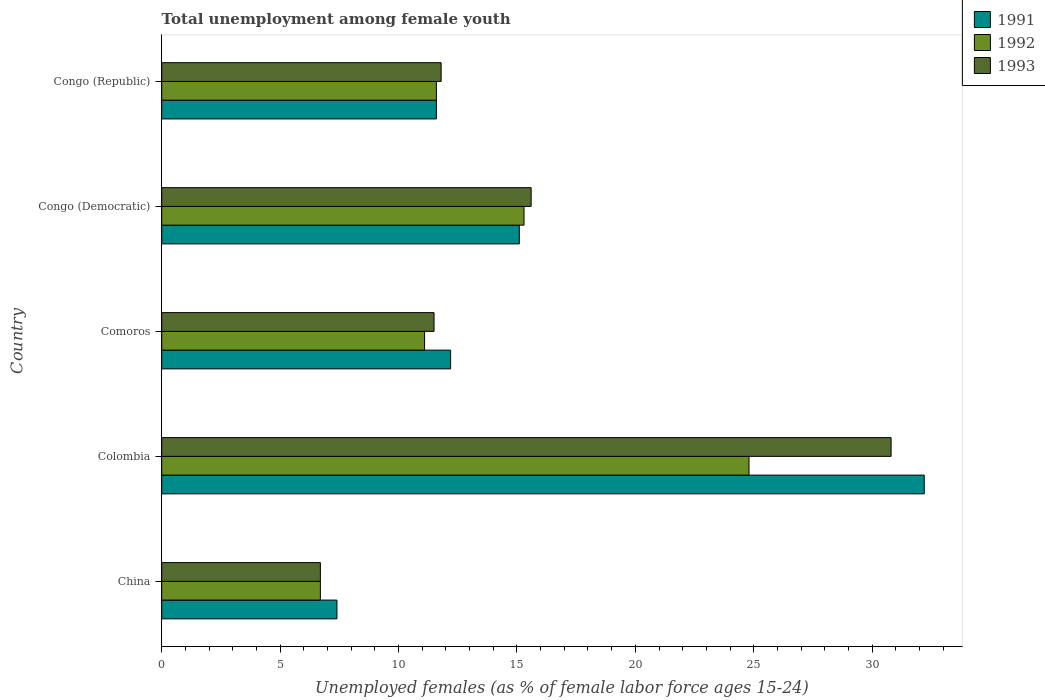How many different coloured bars are there?
Ensure brevity in your answer.  3. Are the number of bars on each tick of the Y-axis equal?
Your answer should be compact. Yes. How many bars are there on the 5th tick from the top?
Your response must be concise. 3. How many bars are there on the 3rd tick from the bottom?
Your answer should be compact. 3. What is the label of the 5th group of bars from the top?
Make the answer very short. China. In how many cases, is the number of bars for a given country not equal to the number of legend labels?
Your answer should be very brief. 0. What is the percentage of unemployed females in in 1993 in China?
Provide a succinct answer. 6.7. Across all countries, what is the maximum percentage of unemployed females in in 1992?
Ensure brevity in your answer.  24.8. Across all countries, what is the minimum percentage of unemployed females in in 1991?
Your answer should be very brief. 7.4. In which country was the percentage of unemployed females in in 1993 maximum?
Offer a terse response. Colombia. What is the total percentage of unemployed females in in 1993 in the graph?
Offer a terse response. 76.4. What is the difference between the percentage of unemployed females in in 1991 in Colombia and that in Congo (Republic)?
Your answer should be compact. 20.6. What is the difference between the percentage of unemployed females in in 1991 in China and the percentage of unemployed females in in 1993 in Colombia?
Offer a terse response. -23.4. What is the average percentage of unemployed females in in 1992 per country?
Keep it short and to the point. 13.9. What is the difference between the percentage of unemployed females in in 1993 and percentage of unemployed females in in 1992 in China?
Provide a short and direct response. 0. In how many countries, is the percentage of unemployed females in in 1991 greater than 11 %?
Keep it short and to the point. 4. What is the ratio of the percentage of unemployed females in in 1993 in Congo (Democratic) to that in Congo (Republic)?
Your answer should be very brief. 1.32. Is the percentage of unemployed females in in 1993 in Colombia less than that in Congo (Democratic)?
Give a very brief answer. No. Is the difference between the percentage of unemployed females in in 1993 in China and Colombia greater than the difference between the percentage of unemployed females in in 1992 in China and Colombia?
Keep it short and to the point. No. What is the difference between the highest and the second highest percentage of unemployed females in in 1993?
Make the answer very short. 15.2. What is the difference between the highest and the lowest percentage of unemployed females in in 1991?
Provide a short and direct response. 24.8. In how many countries, is the percentage of unemployed females in in 1993 greater than the average percentage of unemployed females in in 1993 taken over all countries?
Your answer should be very brief. 2. Is the sum of the percentage of unemployed females in in 1992 in Comoros and Congo (Democratic) greater than the maximum percentage of unemployed females in in 1991 across all countries?
Make the answer very short. No. What does the 2nd bar from the bottom in China represents?
Your response must be concise. 1992. Are all the bars in the graph horizontal?
Provide a succinct answer. Yes. How many countries are there in the graph?
Your answer should be compact. 5. Does the graph contain grids?
Your answer should be compact. No. How many legend labels are there?
Your response must be concise. 3. How are the legend labels stacked?
Your answer should be compact. Vertical. What is the title of the graph?
Provide a succinct answer. Total unemployment among female youth. Does "2009" appear as one of the legend labels in the graph?
Offer a terse response. No. What is the label or title of the X-axis?
Give a very brief answer. Unemployed females (as % of female labor force ages 15-24). What is the Unemployed females (as % of female labor force ages 15-24) in 1991 in China?
Your answer should be very brief. 7.4. What is the Unemployed females (as % of female labor force ages 15-24) of 1992 in China?
Your answer should be very brief. 6.7. What is the Unemployed females (as % of female labor force ages 15-24) in 1993 in China?
Offer a terse response. 6.7. What is the Unemployed females (as % of female labor force ages 15-24) in 1991 in Colombia?
Offer a terse response. 32.2. What is the Unemployed females (as % of female labor force ages 15-24) in 1992 in Colombia?
Ensure brevity in your answer.  24.8. What is the Unemployed females (as % of female labor force ages 15-24) of 1993 in Colombia?
Provide a succinct answer. 30.8. What is the Unemployed females (as % of female labor force ages 15-24) of 1991 in Comoros?
Your answer should be very brief. 12.2. What is the Unemployed females (as % of female labor force ages 15-24) in 1992 in Comoros?
Ensure brevity in your answer.  11.1. What is the Unemployed females (as % of female labor force ages 15-24) of 1993 in Comoros?
Give a very brief answer. 11.5. What is the Unemployed females (as % of female labor force ages 15-24) in 1991 in Congo (Democratic)?
Keep it short and to the point. 15.1. What is the Unemployed females (as % of female labor force ages 15-24) in 1992 in Congo (Democratic)?
Give a very brief answer. 15.3. What is the Unemployed females (as % of female labor force ages 15-24) in 1993 in Congo (Democratic)?
Your answer should be compact. 15.6. What is the Unemployed females (as % of female labor force ages 15-24) of 1991 in Congo (Republic)?
Your response must be concise. 11.6. What is the Unemployed females (as % of female labor force ages 15-24) of 1992 in Congo (Republic)?
Provide a succinct answer. 11.6. What is the Unemployed females (as % of female labor force ages 15-24) in 1993 in Congo (Republic)?
Offer a very short reply. 11.8. Across all countries, what is the maximum Unemployed females (as % of female labor force ages 15-24) in 1991?
Give a very brief answer. 32.2. Across all countries, what is the maximum Unemployed females (as % of female labor force ages 15-24) in 1992?
Ensure brevity in your answer.  24.8. Across all countries, what is the maximum Unemployed females (as % of female labor force ages 15-24) in 1993?
Ensure brevity in your answer.  30.8. Across all countries, what is the minimum Unemployed females (as % of female labor force ages 15-24) in 1991?
Your response must be concise. 7.4. Across all countries, what is the minimum Unemployed females (as % of female labor force ages 15-24) of 1992?
Provide a succinct answer. 6.7. Across all countries, what is the minimum Unemployed females (as % of female labor force ages 15-24) of 1993?
Keep it short and to the point. 6.7. What is the total Unemployed females (as % of female labor force ages 15-24) in 1991 in the graph?
Your answer should be very brief. 78.5. What is the total Unemployed females (as % of female labor force ages 15-24) in 1992 in the graph?
Your answer should be compact. 69.5. What is the total Unemployed females (as % of female labor force ages 15-24) of 1993 in the graph?
Your response must be concise. 76.4. What is the difference between the Unemployed females (as % of female labor force ages 15-24) in 1991 in China and that in Colombia?
Your answer should be compact. -24.8. What is the difference between the Unemployed females (as % of female labor force ages 15-24) in 1992 in China and that in Colombia?
Offer a very short reply. -18.1. What is the difference between the Unemployed females (as % of female labor force ages 15-24) of 1993 in China and that in Colombia?
Offer a very short reply. -24.1. What is the difference between the Unemployed females (as % of female labor force ages 15-24) in 1991 in China and that in Comoros?
Make the answer very short. -4.8. What is the difference between the Unemployed females (as % of female labor force ages 15-24) in 1991 in China and that in Congo (Democratic)?
Keep it short and to the point. -7.7. What is the difference between the Unemployed females (as % of female labor force ages 15-24) in 1991 in China and that in Congo (Republic)?
Your answer should be compact. -4.2. What is the difference between the Unemployed females (as % of female labor force ages 15-24) in 1993 in China and that in Congo (Republic)?
Provide a succinct answer. -5.1. What is the difference between the Unemployed females (as % of female labor force ages 15-24) in 1992 in Colombia and that in Comoros?
Provide a short and direct response. 13.7. What is the difference between the Unemployed females (as % of female labor force ages 15-24) in 1993 in Colombia and that in Comoros?
Provide a succinct answer. 19.3. What is the difference between the Unemployed females (as % of female labor force ages 15-24) of 1991 in Colombia and that in Congo (Democratic)?
Keep it short and to the point. 17.1. What is the difference between the Unemployed females (as % of female labor force ages 15-24) in 1993 in Colombia and that in Congo (Democratic)?
Ensure brevity in your answer.  15.2. What is the difference between the Unemployed females (as % of female labor force ages 15-24) of 1991 in Colombia and that in Congo (Republic)?
Give a very brief answer. 20.6. What is the difference between the Unemployed females (as % of female labor force ages 15-24) in 1993 in Colombia and that in Congo (Republic)?
Your response must be concise. 19. What is the difference between the Unemployed females (as % of female labor force ages 15-24) of 1991 in Comoros and that in Congo (Democratic)?
Offer a terse response. -2.9. What is the difference between the Unemployed females (as % of female labor force ages 15-24) of 1992 in Comoros and that in Congo (Democratic)?
Make the answer very short. -4.2. What is the difference between the Unemployed females (as % of female labor force ages 15-24) of 1993 in Comoros and that in Congo (Democratic)?
Your answer should be compact. -4.1. What is the difference between the Unemployed females (as % of female labor force ages 15-24) of 1992 in Comoros and that in Congo (Republic)?
Make the answer very short. -0.5. What is the difference between the Unemployed females (as % of female labor force ages 15-24) in 1993 in Comoros and that in Congo (Republic)?
Keep it short and to the point. -0.3. What is the difference between the Unemployed females (as % of female labor force ages 15-24) of 1993 in Congo (Democratic) and that in Congo (Republic)?
Offer a terse response. 3.8. What is the difference between the Unemployed females (as % of female labor force ages 15-24) of 1991 in China and the Unemployed females (as % of female labor force ages 15-24) of 1992 in Colombia?
Give a very brief answer. -17.4. What is the difference between the Unemployed females (as % of female labor force ages 15-24) of 1991 in China and the Unemployed females (as % of female labor force ages 15-24) of 1993 in Colombia?
Provide a succinct answer. -23.4. What is the difference between the Unemployed females (as % of female labor force ages 15-24) in 1992 in China and the Unemployed females (as % of female labor force ages 15-24) in 1993 in Colombia?
Offer a very short reply. -24.1. What is the difference between the Unemployed females (as % of female labor force ages 15-24) in 1991 in China and the Unemployed females (as % of female labor force ages 15-24) in 1993 in Comoros?
Provide a short and direct response. -4.1. What is the difference between the Unemployed females (as % of female labor force ages 15-24) in 1992 in China and the Unemployed females (as % of female labor force ages 15-24) in 1993 in Comoros?
Your answer should be compact. -4.8. What is the difference between the Unemployed females (as % of female labor force ages 15-24) of 1991 in China and the Unemployed females (as % of female labor force ages 15-24) of 1992 in Congo (Democratic)?
Provide a succinct answer. -7.9. What is the difference between the Unemployed females (as % of female labor force ages 15-24) of 1991 in China and the Unemployed females (as % of female labor force ages 15-24) of 1993 in Congo (Democratic)?
Offer a very short reply. -8.2. What is the difference between the Unemployed females (as % of female labor force ages 15-24) of 1991 in Colombia and the Unemployed females (as % of female labor force ages 15-24) of 1992 in Comoros?
Offer a very short reply. 21.1. What is the difference between the Unemployed females (as % of female labor force ages 15-24) in 1991 in Colombia and the Unemployed females (as % of female labor force ages 15-24) in 1993 in Comoros?
Make the answer very short. 20.7. What is the difference between the Unemployed females (as % of female labor force ages 15-24) of 1992 in Colombia and the Unemployed females (as % of female labor force ages 15-24) of 1993 in Congo (Democratic)?
Keep it short and to the point. 9.2. What is the difference between the Unemployed females (as % of female labor force ages 15-24) of 1991 in Colombia and the Unemployed females (as % of female labor force ages 15-24) of 1992 in Congo (Republic)?
Your response must be concise. 20.6. What is the difference between the Unemployed females (as % of female labor force ages 15-24) in 1991 in Colombia and the Unemployed females (as % of female labor force ages 15-24) in 1993 in Congo (Republic)?
Ensure brevity in your answer.  20.4. What is the difference between the Unemployed females (as % of female labor force ages 15-24) in 1991 in Comoros and the Unemployed females (as % of female labor force ages 15-24) in 1992 in Congo (Republic)?
Keep it short and to the point. 0.6. What is the difference between the Unemployed females (as % of female labor force ages 15-24) of 1991 in Comoros and the Unemployed females (as % of female labor force ages 15-24) of 1993 in Congo (Republic)?
Provide a short and direct response. 0.4. What is the difference between the Unemployed females (as % of female labor force ages 15-24) of 1991 in Congo (Democratic) and the Unemployed females (as % of female labor force ages 15-24) of 1992 in Congo (Republic)?
Give a very brief answer. 3.5. What is the difference between the Unemployed females (as % of female labor force ages 15-24) in 1992 in Congo (Democratic) and the Unemployed females (as % of female labor force ages 15-24) in 1993 in Congo (Republic)?
Give a very brief answer. 3.5. What is the average Unemployed females (as % of female labor force ages 15-24) of 1993 per country?
Make the answer very short. 15.28. What is the difference between the Unemployed females (as % of female labor force ages 15-24) of 1991 and Unemployed females (as % of female labor force ages 15-24) of 1992 in China?
Keep it short and to the point. 0.7. What is the difference between the Unemployed females (as % of female labor force ages 15-24) of 1992 and Unemployed females (as % of female labor force ages 15-24) of 1993 in China?
Keep it short and to the point. 0. What is the difference between the Unemployed females (as % of female labor force ages 15-24) in 1992 and Unemployed females (as % of female labor force ages 15-24) in 1993 in Comoros?
Keep it short and to the point. -0.4. What is the difference between the Unemployed females (as % of female labor force ages 15-24) in 1991 and Unemployed females (as % of female labor force ages 15-24) in 1992 in Congo (Democratic)?
Your answer should be very brief. -0.2. What is the difference between the Unemployed females (as % of female labor force ages 15-24) of 1991 and Unemployed females (as % of female labor force ages 15-24) of 1993 in Congo (Democratic)?
Make the answer very short. -0.5. What is the difference between the Unemployed females (as % of female labor force ages 15-24) in 1992 and Unemployed females (as % of female labor force ages 15-24) in 1993 in Congo (Democratic)?
Your answer should be very brief. -0.3. What is the ratio of the Unemployed females (as % of female labor force ages 15-24) in 1991 in China to that in Colombia?
Your answer should be compact. 0.23. What is the ratio of the Unemployed females (as % of female labor force ages 15-24) of 1992 in China to that in Colombia?
Your answer should be very brief. 0.27. What is the ratio of the Unemployed females (as % of female labor force ages 15-24) of 1993 in China to that in Colombia?
Offer a very short reply. 0.22. What is the ratio of the Unemployed females (as % of female labor force ages 15-24) in 1991 in China to that in Comoros?
Make the answer very short. 0.61. What is the ratio of the Unemployed females (as % of female labor force ages 15-24) of 1992 in China to that in Comoros?
Provide a short and direct response. 0.6. What is the ratio of the Unemployed females (as % of female labor force ages 15-24) in 1993 in China to that in Comoros?
Offer a terse response. 0.58. What is the ratio of the Unemployed females (as % of female labor force ages 15-24) in 1991 in China to that in Congo (Democratic)?
Keep it short and to the point. 0.49. What is the ratio of the Unemployed females (as % of female labor force ages 15-24) of 1992 in China to that in Congo (Democratic)?
Offer a very short reply. 0.44. What is the ratio of the Unemployed females (as % of female labor force ages 15-24) in 1993 in China to that in Congo (Democratic)?
Your response must be concise. 0.43. What is the ratio of the Unemployed females (as % of female labor force ages 15-24) in 1991 in China to that in Congo (Republic)?
Keep it short and to the point. 0.64. What is the ratio of the Unemployed females (as % of female labor force ages 15-24) of 1992 in China to that in Congo (Republic)?
Keep it short and to the point. 0.58. What is the ratio of the Unemployed females (as % of female labor force ages 15-24) in 1993 in China to that in Congo (Republic)?
Offer a terse response. 0.57. What is the ratio of the Unemployed females (as % of female labor force ages 15-24) in 1991 in Colombia to that in Comoros?
Your answer should be compact. 2.64. What is the ratio of the Unemployed females (as % of female labor force ages 15-24) in 1992 in Colombia to that in Comoros?
Provide a succinct answer. 2.23. What is the ratio of the Unemployed females (as % of female labor force ages 15-24) in 1993 in Colombia to that in Comoros?
Make the answer very short. 2.68. What is the ratio of the Unemployed females (as % of female labor force ages 15-24) of 1991 in Colombia to that in Congo (Democratic)?
Your answer should be very brief. 2.13. What is the ratio of the Unemployed females (as % of female labor force ages 15-24) in 1992 in Colombia to that in Congo (Democratic)?
Your answer should be very brief. 1.62. What is the ratio of the Unemployed females (as % of female labor force ages 15-24) of 1993 in Colombia to that in Congo (Democratic)?
Offer a very short reply. 1.97. What is the ratio of the Unemployed females (as % of female labor force ages 15-24) of 1991 in Colombia to that in Congo (Republic)?
Your response must be concise. 2.78. What is the ratio of the Unemployed females (as % of female labor force ages 15-24) of 1992 in Colombia to that in Congo (Republic)?
Provide a succinct answer. 2.14. What is the ratio of the Unemployed females (as % of female labor force ages 15-24) of 1993 in Colombia to that in Congo (Republic)?
Ensure brevity in your answer.  2.61. What is the ratio of the Unemployed females (as % of female labor force ages 15-24) of 1991 in Comoros to that in Congo (Democratic)?
Make the answer very short. 0.81. What is the ratio of the Unemployed females (as % of female labor force ages 15-24) of 1992 in Comoros to that in Congo (Democratic)?
Keep it short and to the point. 0.73. What is the ratio of the Unemployed females (as % of female labor force ages 15-24) of 1993 in Comoros to that in Congo (Democratic)?
Provide a succinct answer. 0.74. What is the ratio of the Unemployed females (as % of female labor force ages 15-24) of 1991 in Comoros to that in Congo (Republic)?
Ensure brevity in your answer.  1.05. What is the ratio of the Unemployed females (as % of female labor force ages 15-24) of 1992 in Comoros to that in Congo (Republic)?
Keep it short and to the point. 0.96. What is the ratio of the Unemployed females (as % of female labor force ages 15-24) of 1993 in Comoros to that in Congo (Republic)?
Make the answer very short. 0.97. What is the ratio of the Unemployed females (as % of female labor force ages 15-24) of 1991 in Congo (Democratic) to that in Congo (Republic)?
Keep it short and to the point. 1.3. What is the ratio of the Unemployed females (as % of female labor force ages 15-24) in 1992 in Congo (Democratic) to that in Congo (Republic)?
Your answer should be compact. 1.32. What is the ratio of the Unemployed females (as % of female labor force ages 15-24) in 1993 in Congo (Democratic) to that in Congo (Republic)?
Your response must be concise. 1.32. What is the difference between the highest and the second highest Unemployed females (as % of female labor force ages 15-24) of 1991?
Make the answer very short. 17.1. What is the difference between the highest and the second highest Unemployed females (as % of female labor force ages 15-24) in 1993?
Offer a very short reply. 15.2. What is the difference between the highest and the lowest Unemployed females (as % of female labor force ages 15-24) in 1991?
Your answer should be compact. 24.8. What is the difference between the highest and the lowest Unemployed females (as % of female labor force ages 15-24) in 1993?
Your answer should be compact. 24.1. 